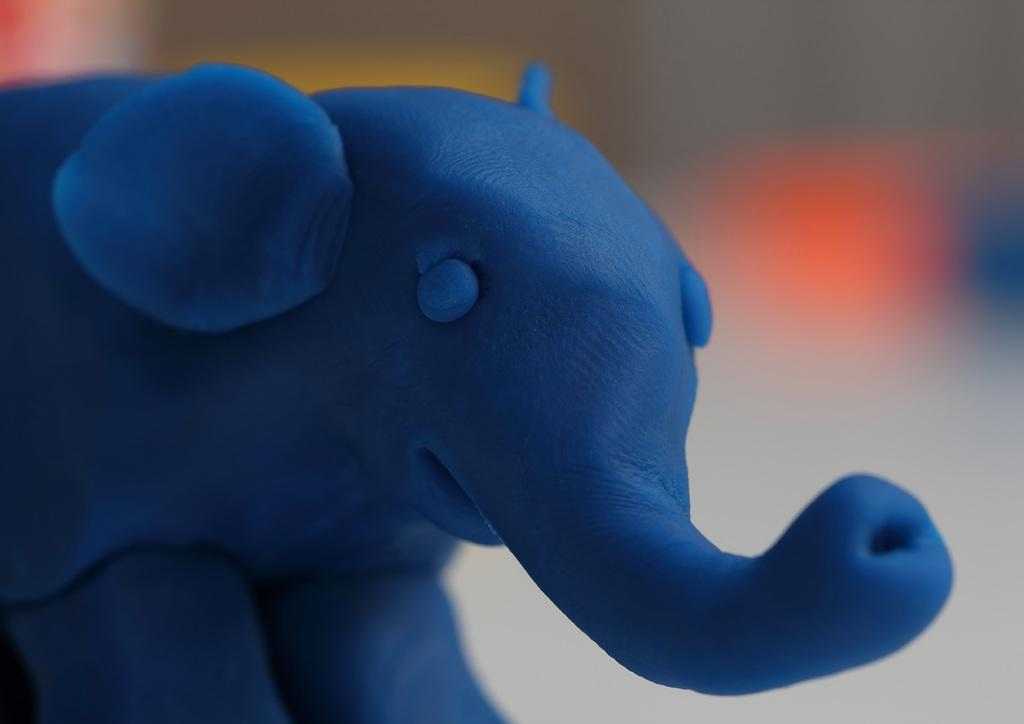What is the main subject of the image? The main subject of the image is an elephant made out of colored clay. Can you describe the appearance of the elephant? The elephant is made out of colored clay. What can be observed about the background of the image? The background of the image is blurred. What type of soda is being served in the image? There is no soda present in the image; it features an elephant made out of colored clay. Can you tell me who made the art in the image? The facts provided do not mention the artist or creator of the elephant made out of colored clay. 